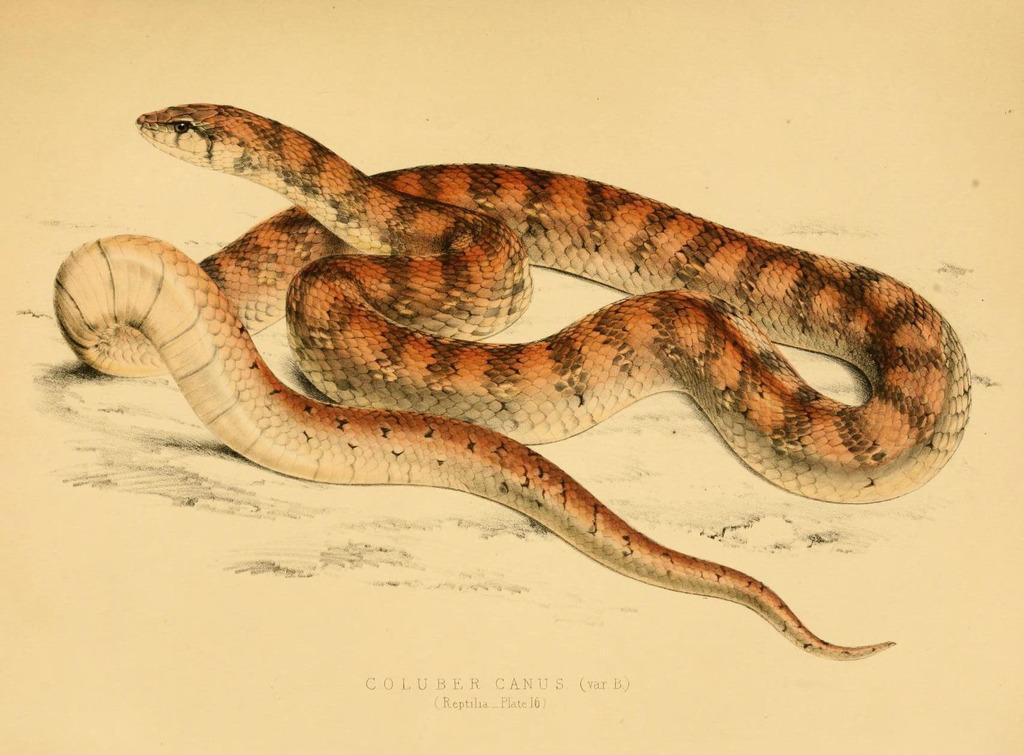Please provide a concise description of this image. In this image I can see depiction of a snake. I can also see color of the snake is brown and cream. I can also see something is written on the bottom side of the image. 